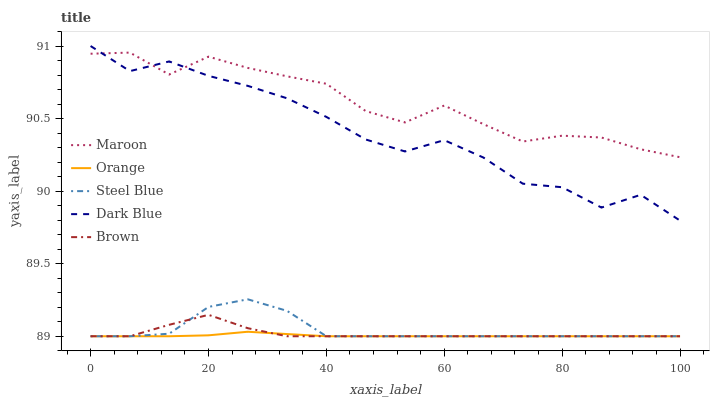Does Orange have the minimum area under the curve?
Answer yes or no. Yes. Does Maroon have the maximum area under the curve?
Answer yes or no. Yes. Does Dark Blue have the minimum area under the curve?
Answer yes or no. No. Does Dark Blue have the maximum area under the curve?
Answer yes or no. No. Is Orange the smoothest?
Answer yes or no. Yes. Is Dark Blue the roughest?
Answer yes or no. Yes. Is Steel Blue the smoothest?
Answer yes or no. No. Is Steel Blue the roughest?
Answer yes or no. No. Does Orange have the lowest value?
Answer yes or no. Yes. Does Dark Blue have the lowest value?
Answer yes or no. No. Does Dark Blue have the highest value?
Answer yes or no. Yes. Does Steel Blue have the highest value?
Answer yes or no. No. Is Steel Blue less than Dark Blue?
Answer yes or no. Yes. Is Dark Blue greater than Brown?
Answer yes or no. Yes. Does Maroon intersect Dark Blue?
Answer yes or no. Yes. Is Maroon less than Dark Blue?
Answer yes or no. No. Is Maroon greater than Dark Blue?
Answer yes or no. No. Does Steel Blue intersect Dark Blue?
Answer yes or no. No. 